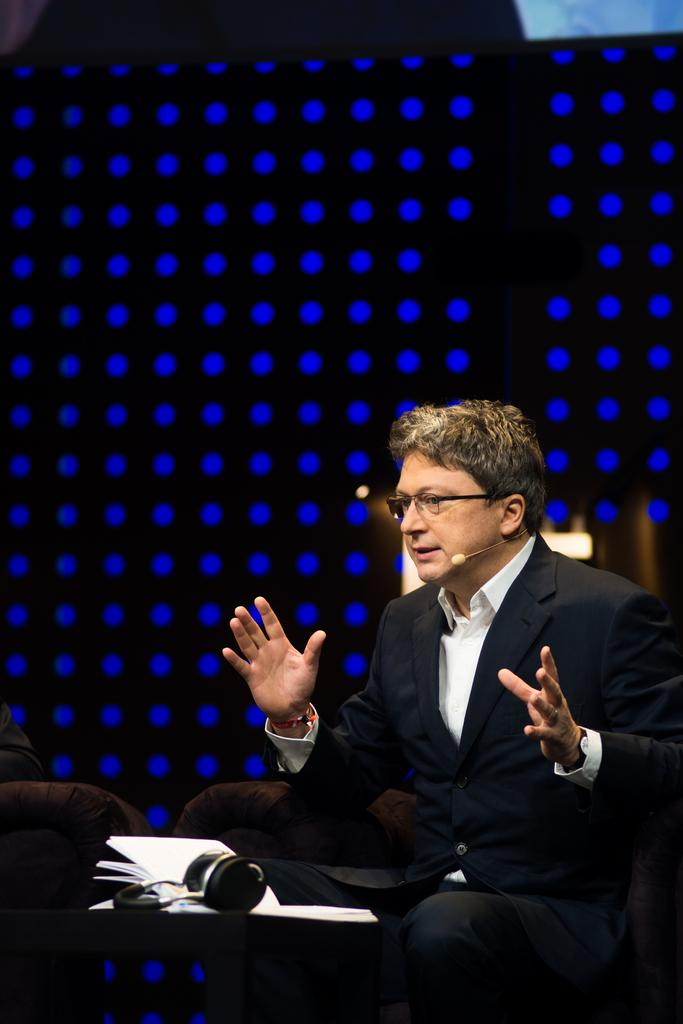What is the person in the image doing? The person is sitting on a chair in the image. What is the person wearing? The person is wearing a black and white dress. What objects are in front of the person? Papers and a headset are visible in front of the person. What colors can be seen in the background of the image? The background of the image has black and blue colors. What type of veil can be seen covering the person's face in the image? There is no veil present in the image; the person is wearing a black and white dress. Can you tell me how many people are dancing at the club in the image? There is no club or dancing people present in the image; it features a person sitting on a chair with papers and a headset in front of them. 